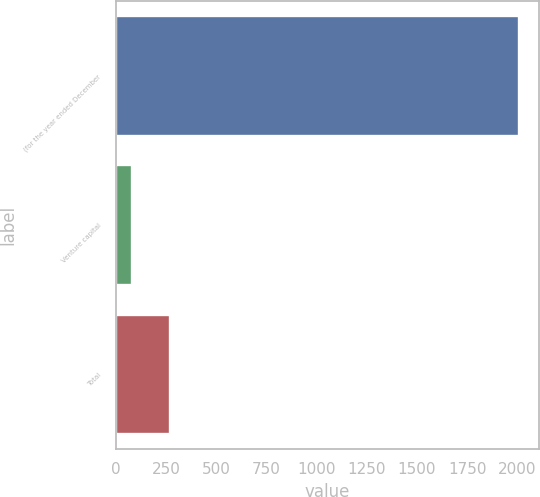<chart> <loc_0><loc_0><loc_500><loc_500><bar_chart><fcel>(for the year ended December<fcel>Venture capital<fcel>Total<nl><fcel>2005<fcel>80<fcel>272.5<nl></chart> 